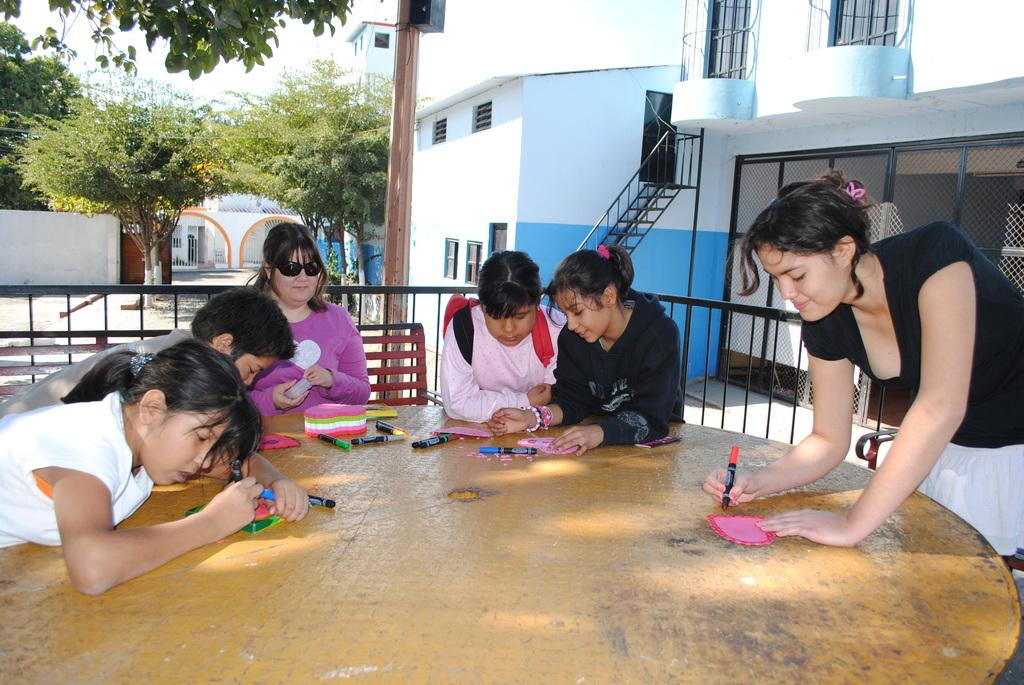Who or what is present in the image? There are people in the image. What object can be seen in the image that might be used for eating or working on? There is a table in the image. What are some people holding in the image? Some people are holding markers. What can be seen in the distance in the image? There are trees and buildings in the background of the image. What type of cake is being served at the table in the image? There is no cake present in the image; people are holding markers and there is a table, but no cake. What kind of noise can be heard coming from the people in the image? The image is static, so no noise can be heard. 